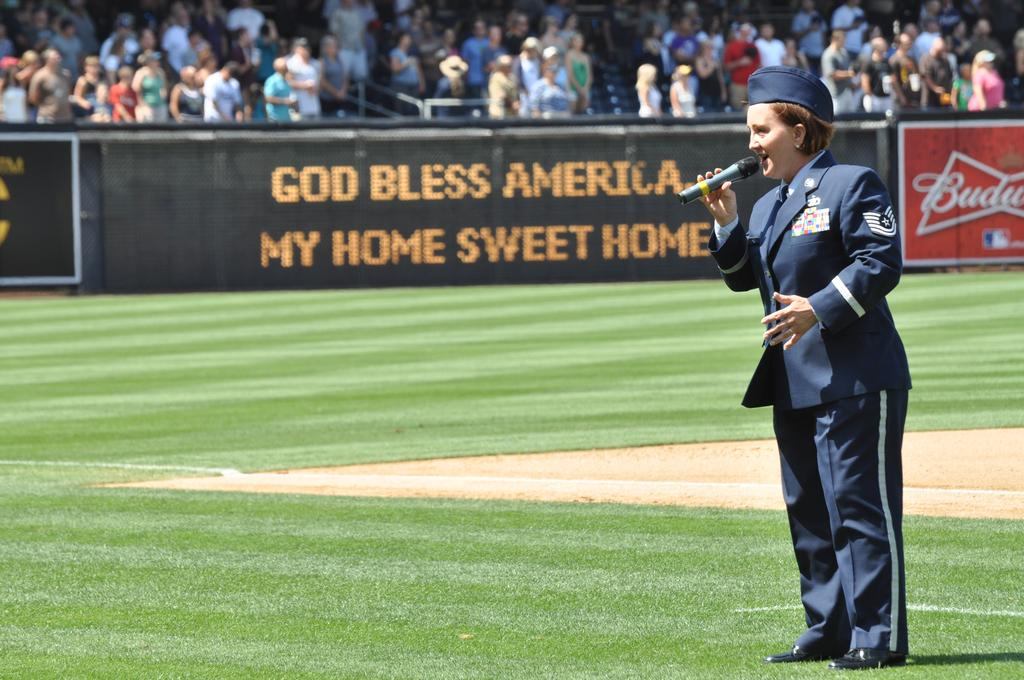<image>
Give a short and clear explanation of the subsequent image. A woman in the Air Force stands singing in the ball field with God Bless America behind her. 